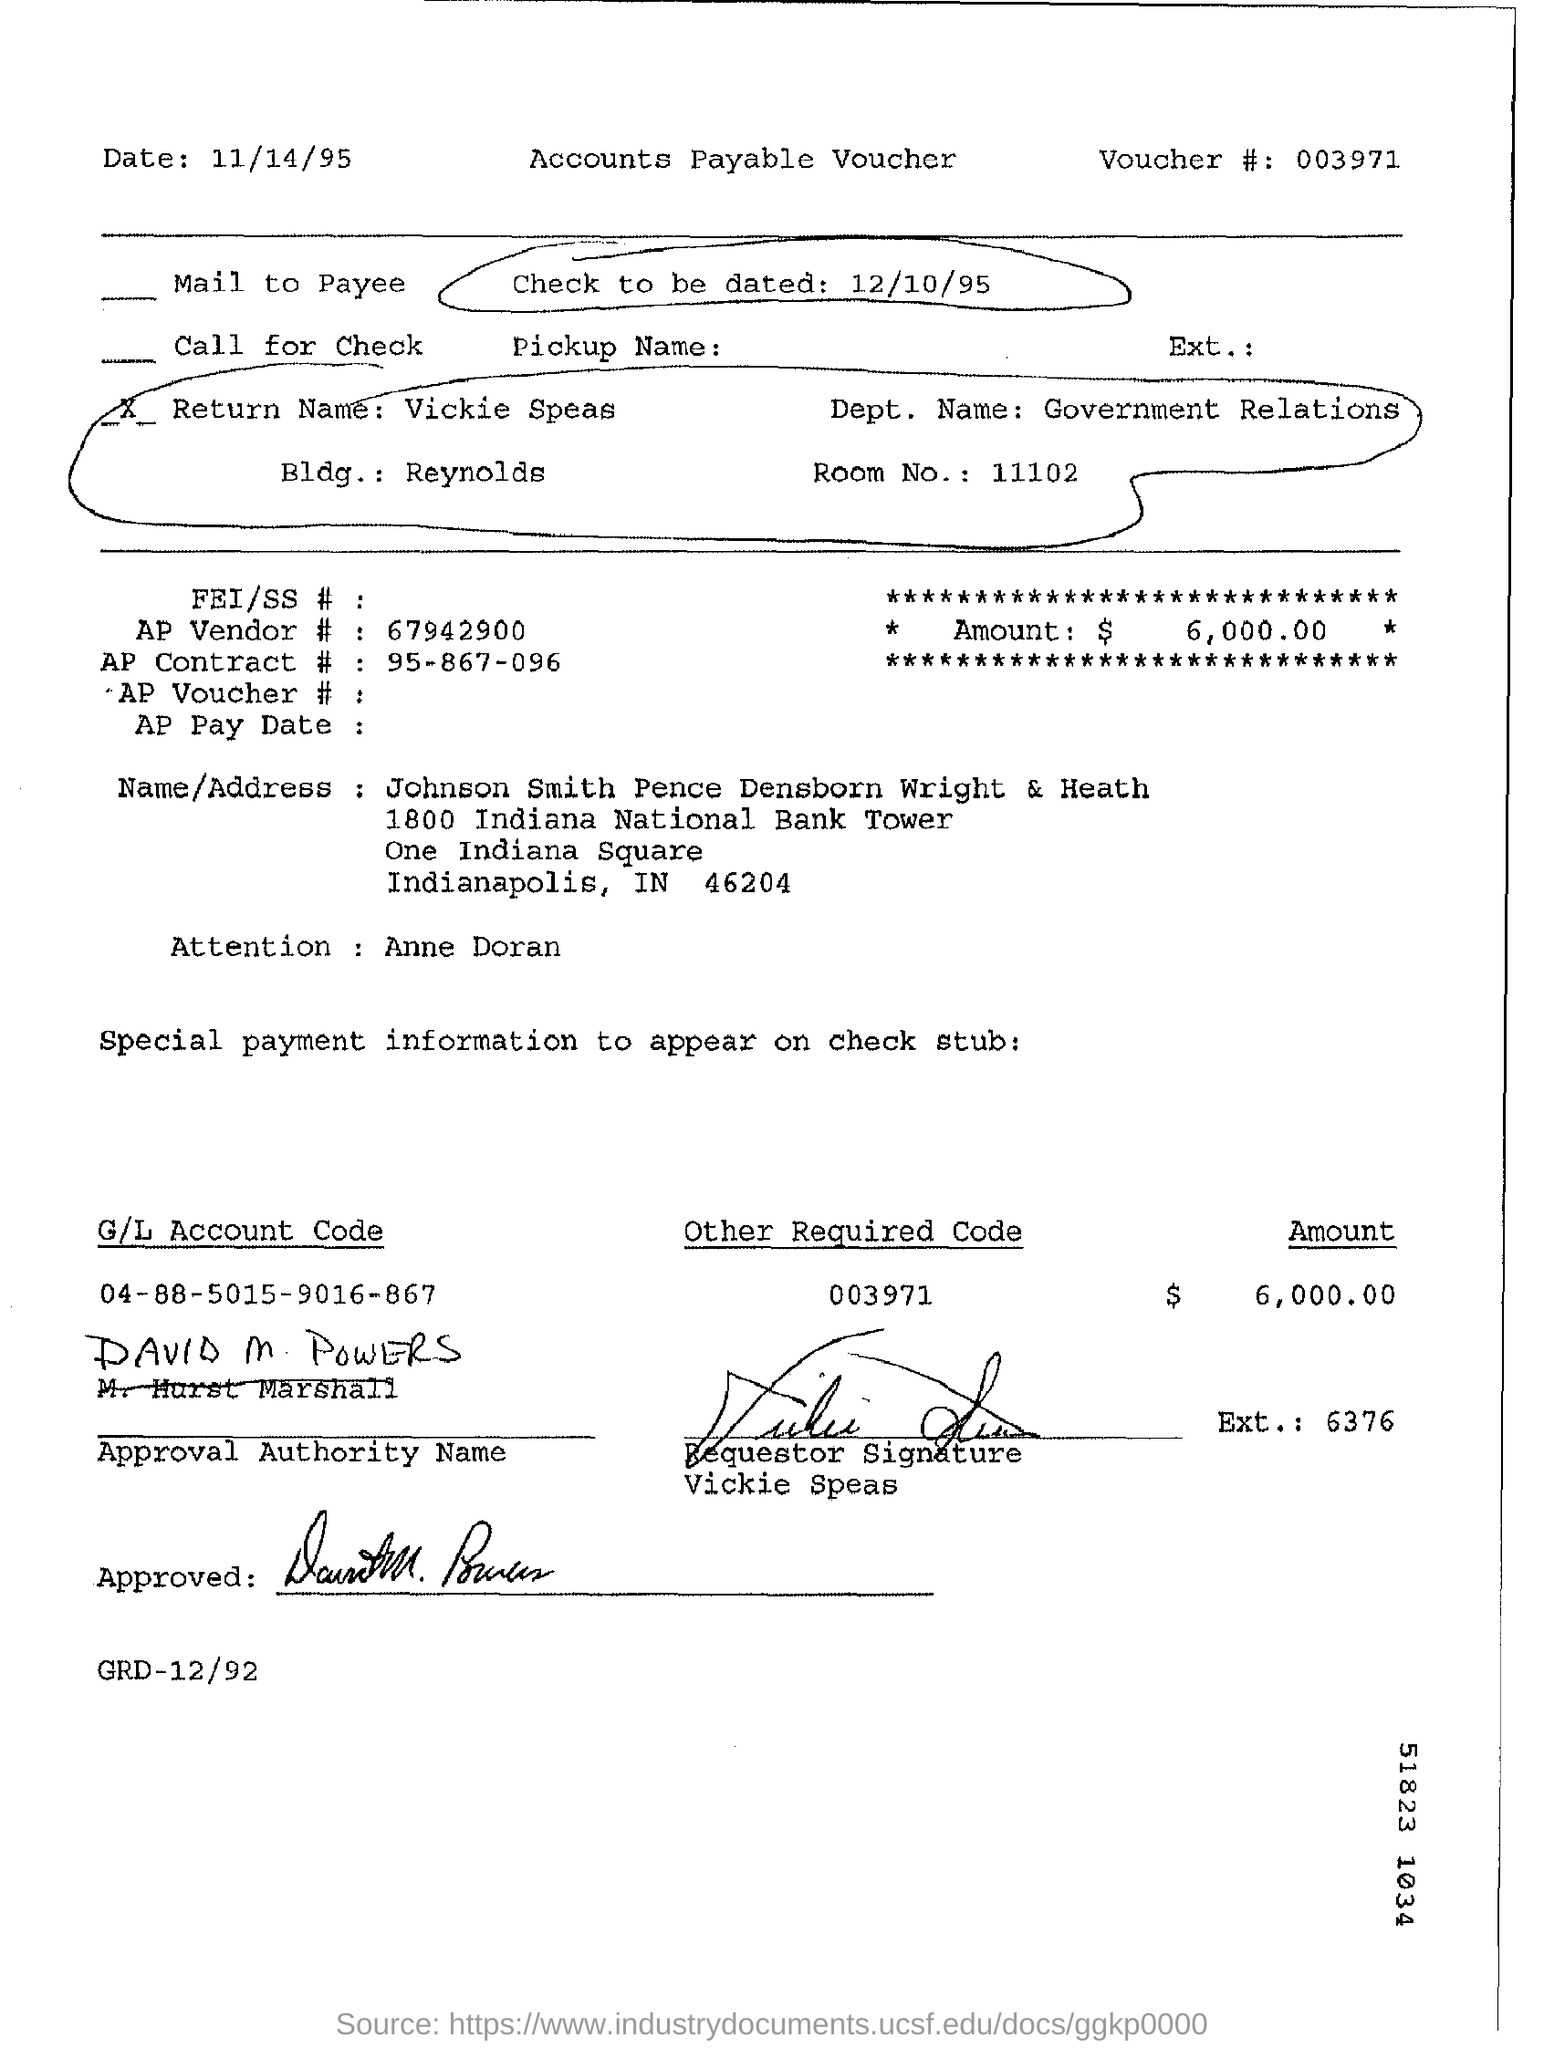Point out several critical features in this image. I need to know the date of the check. Specifically, it needs to be dated 12/10/95. The voucher number provided in the form is 003971... The G/L account code mentioned is 04-88-5015-9016-867. The department name provided is government relations. 